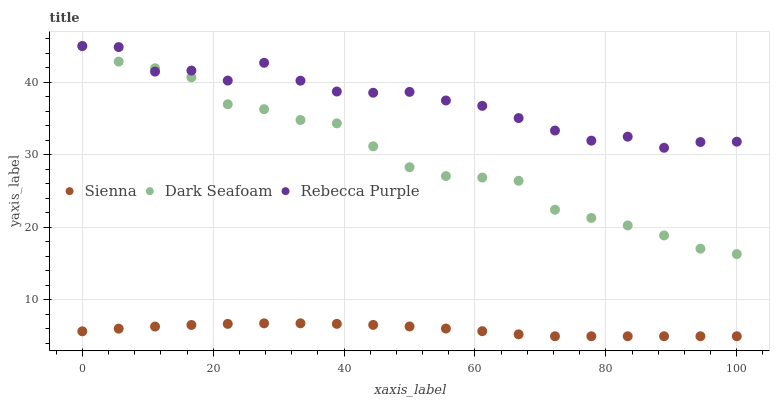Does Sienna have the minimum area under the curve?
Answer yes or no. Yes. Does Rebecca Purple have the maximum area under the curve?
Answer yes or no. Yes. Does Dark Seafoam have the minimum area under the curve?
Answer yes or no. No. Does Dark Seafoam have the maximum area under the curve?
Answer yes or no. No. Is Sienna the smoothest?
Answer yes or no. Yes. Is Rebecca Purple the roughest?
Answer yes or no. Yes. Is Dark Seafoam the smoothest?
Answer yes or no. No. Is Dark Seafoam the roughest?
Answer yes or no. No. Does Sienna have the lowest value?
Answer yes or no. Yes. Does Dark Seafoam have the lowest value?
Answer yes or no. No. Does Rebecca Purple have the highest value?
Answer yes or no. Yes. Is Sienna less than Dark Seafoam?
Answer yes or no. Yes. Is Dark Seafoam greater than Sienna?
Answer yes or no. Yes. Does Rebecca Purple intersect Dark Seafoam?
Answer yes or no. Yes. Is Rebecca Purple less than Dark Seafoam?
Answer yes or no. No. Is Rebecca Purple greater than Dark Seafoam?
Answer yes or no. No. Does Sienna intersect Dark Seafoam?
Answer yes or no. No. 